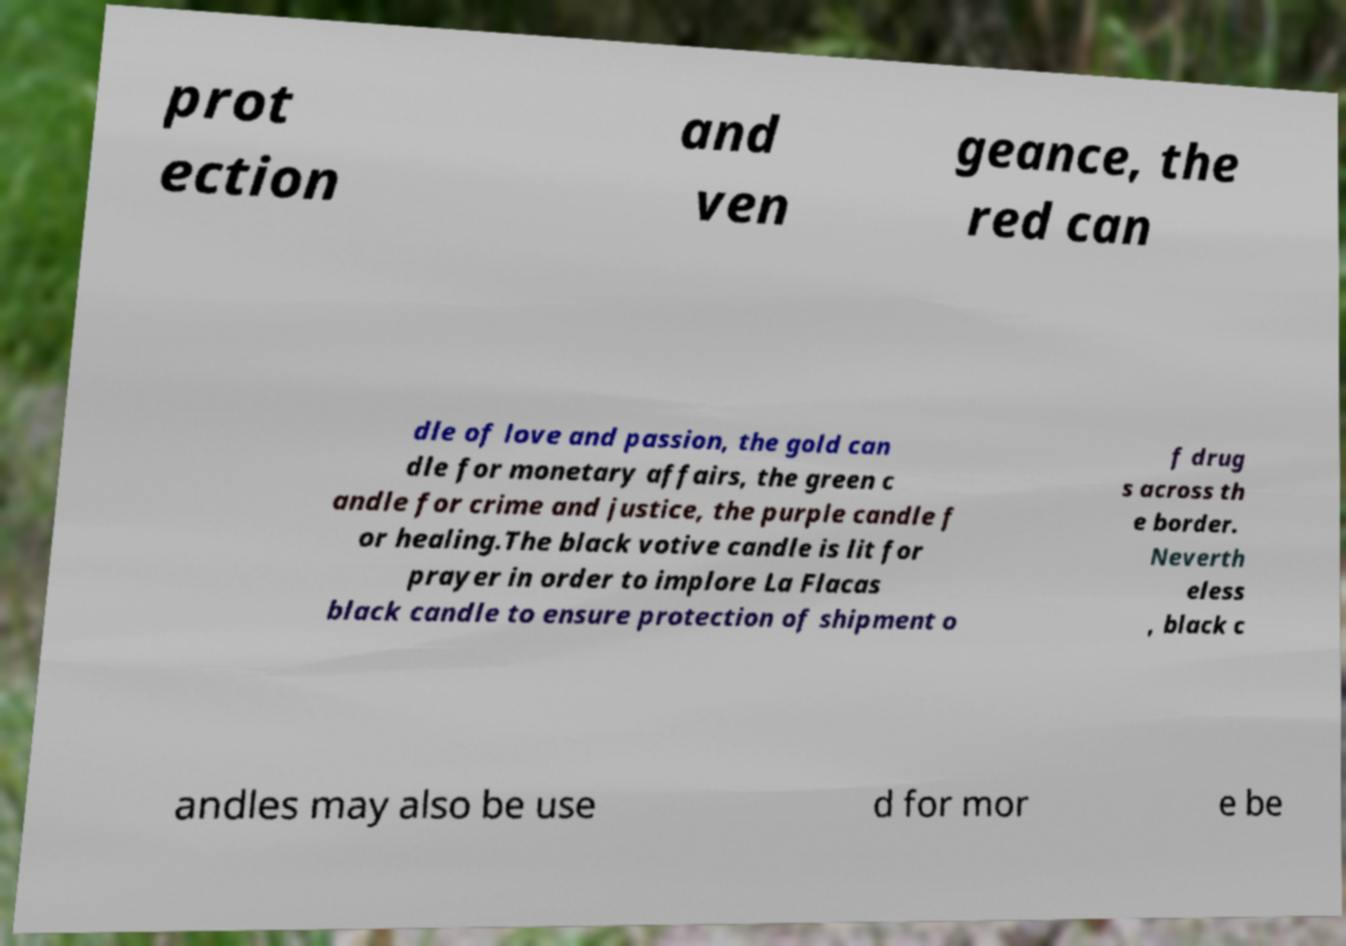Please read and relay the text visible in this image. What does it say? prot ection and ven geance, the red can dle of love and passion, the gold can dle for monetary affairs, the green c andle for crime and justice, the purple candle f or healing.The black votive candle is lit for prayer in order to implore La Flacas black candle to ensure protection of shipment o f drug s across th e border. Neverth eless , black c andles may also be use d for mor e be 